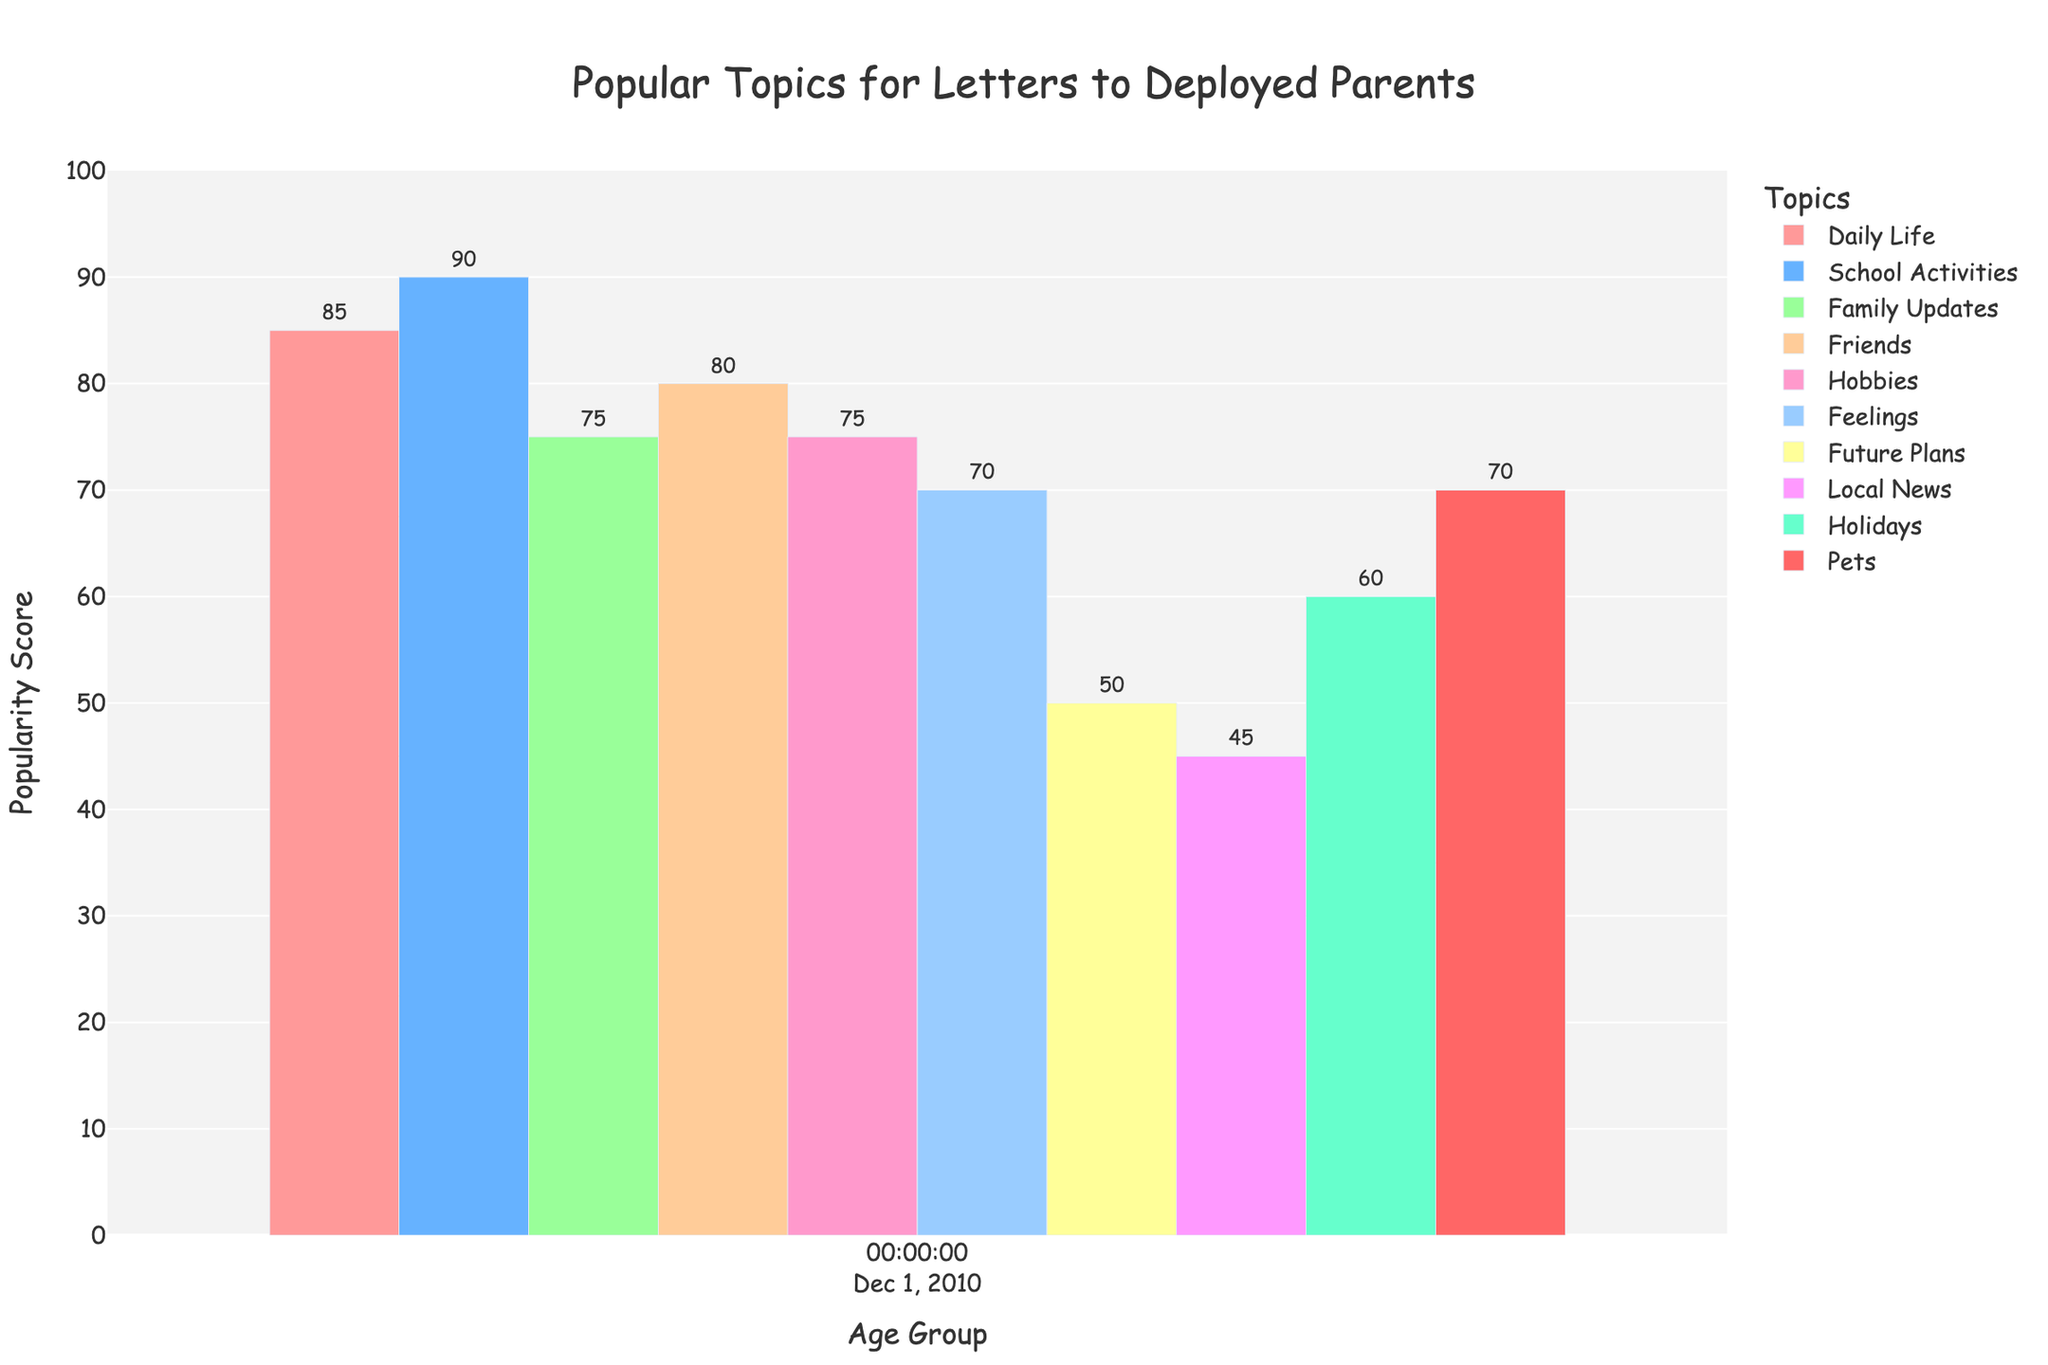Which age group talks the most about 'School Activities'? To find the age group that talks the most about 'School Activities,' look for the highest bar in the 'School Activities' category. The data points for 'School Activities' are: 6-9 (85), 10-12 (90), 13-15 (95), 16-18 (85). Hence, the age group 13-15 has the highest value with 95.
Answer: 13-15 Which topics are equally popular among the 6-9 age group? To identify equally popular topics, compare the popularity scores within the 6-9 age group. The relevant data points are: Daily Life (90), School Activities (85), Family Updates (80), Friends (70), Hobbies (65), Feelings (60), Future Plans (40), Local News (30), Holidays (55), Pets (75). None of these pairs share the same value.
Answer: None Which age group finds 'Pets' least interesting? To determine the age group that finds 'Pets' least interesting, look for the lowest bar in 'Pets' for each age group. The data points are: 6-9 (75), 10-12 (70), 13-15 (60), 16-18 (55). The smallest value is 55 in the age group 16-18.
Answer: 16-18 By how much do 'Feelings' scores differ between the 10-12 and 13-15 age groups? To find the difference, subtract the 'Feelings' score for the 10-12 group from the score for the 13-15 group. The data points are: 10-12 (70), 13-15 (80). Thus, 80 - 70 = 10.
Answer: 10 What is the average popularity score of 'Friends' across all age groups? Calculate the average popularity score by summing the 'Friends' scores for all age groups, and then divide by the number of age groups. The data points are: 6-9 (70), 10-12 (80), 13-15 (85), 16-18 (80). The sum is 70 + 80 + 85 + 80 = 315. The number of groups is 4. Thus, the average is 315/4 = 78.75.
Answer: 78.75 Are there more age groups with a 'Daily Life' score above or below 80? To determine this, count the age groups with 'Daily Life' scores above and below 80. The values are: 6-9 (90), 10-12 (85), 13-15 (75), 16-18 (70). Scores above 80: 2 (6-9 and 10-12). Scores below 80: 2 (13-15 and 16-18). Both counts are identical.
Answer: Equal Which age group has the smallest range of scores across all topics? To find the smallest range of scores, calculate the range for each age group by subtracting the minimum score from the maximum score for each group. The data points are: 6-9 (30 to 90), 10-12 (45 to 90), 13-15 (55 to 95), 16-18 (55 to 85). The ranges are: 6-9 (60), 10-12 (45), 13-15 (40), 16-18 (30). Hence, the 16-18 group has the smallest range of 30.
Answer: 16-18 What visual attribute indicates the most popular topic in each age group? The height of the bar in each topic category indicates popularity. The tallest bar in each age group represents the most popular topic. The tallest bars are: 6-9 (Daily Life - 90), 10-12 (School Activities - 90), 13-15 (School Activities - 95), 16-18 (Feelings - 85).
Answer: The height of the bars What colors are used for 'Feelings' and 'Future Plans' bars? By observing the visual representation, the color of 'Feelings' bars is light pink (#FF99CC) and 'Future Plans' is light yellow (#FFFF99). These colors help in visually distinguishing the two topics.
Answer: Pink and Yellow 